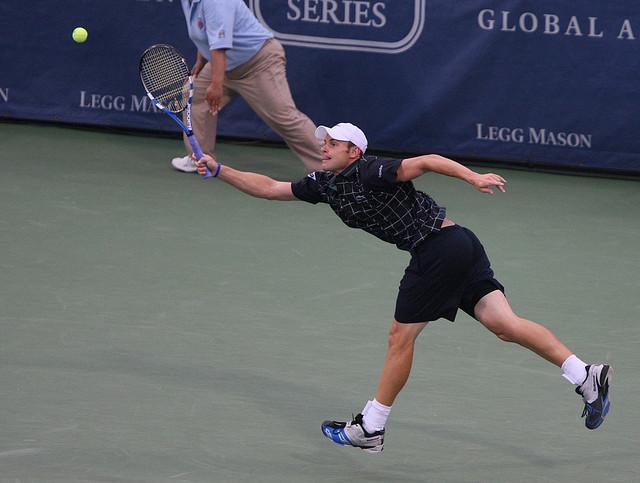Is the man going to hit the ball?
Concise answer only. Yes. What is the brand of clothes the man is wearing?
Answer briefly. Adidas. What kind of surface is he playing tennis on?
Give a very brief answer. Concrete. What color hat is the man with blue shoes wearing?
Write a very short answer. White. What does the man wear to wipe his sweat?
Quick response, please. Shirt. What word starts with a G?
Concise answer only. Global. What color(s) is the tennis player's shoes?
Short answer required. Blue. What color band is around the man's right wrist?
Quick response, please. Blue. 